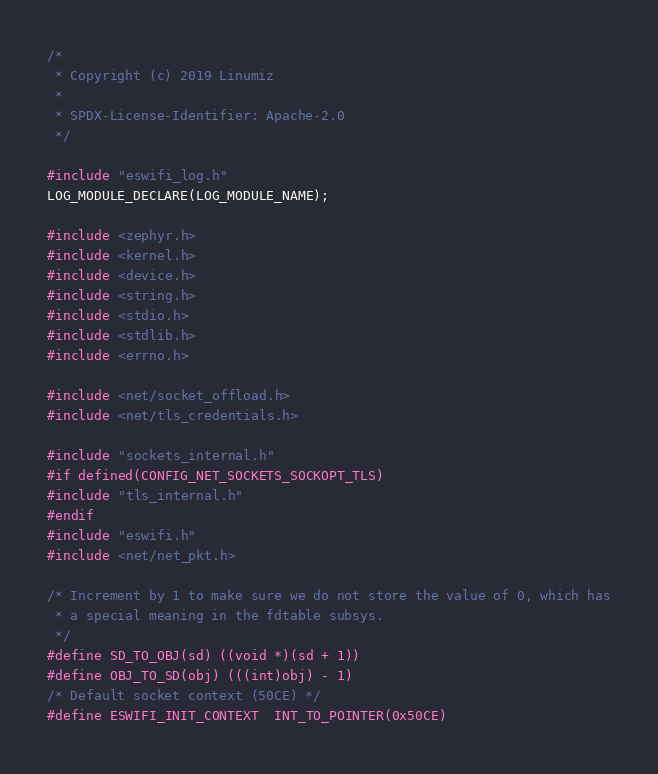<code> <loc_0><loc_0><loc_500><loc_500><_C_>/*
 * Copyright (c) 2019 Linumiz
 *
 * SPDX-License-Identifier: Apache-2.0
 */

#include "eswifi_log.h"
LOG_MODULE_DECLARE(LOG_MODULE_NAME);

#include <zephyr.h>
#include <kernel.h>
#include <device.h>
#include <string.h>
#include <stdio.h>
#include <stdlib.h>
#include <errno.h>

#include <net/socket_offload.h>
#include <net/tls_credentials.h>

#include "sockets_internal.h"
#if defined(CONFIG_NET_SOCKETS_SOCKOPT_TLS)
#include "tls_internal.h"
#endif
#include "eswifi.h"
#include <net/net_pkt.h>

/* Increment by 1 to make sure we do not store the value of 0, which has
 * a special meaning in the fdtable subsys.
 */
#define SD_TO_OBJ(sd) ((void *)(sd + 1))
#define OBJ_TO_SD(obj) (((int)obj) - 1)
/* Default socket context (50CE) */
#define ESWIFI_INIT_CONTEXT	INT_TO_POINTER(0x50CE)
</code> 